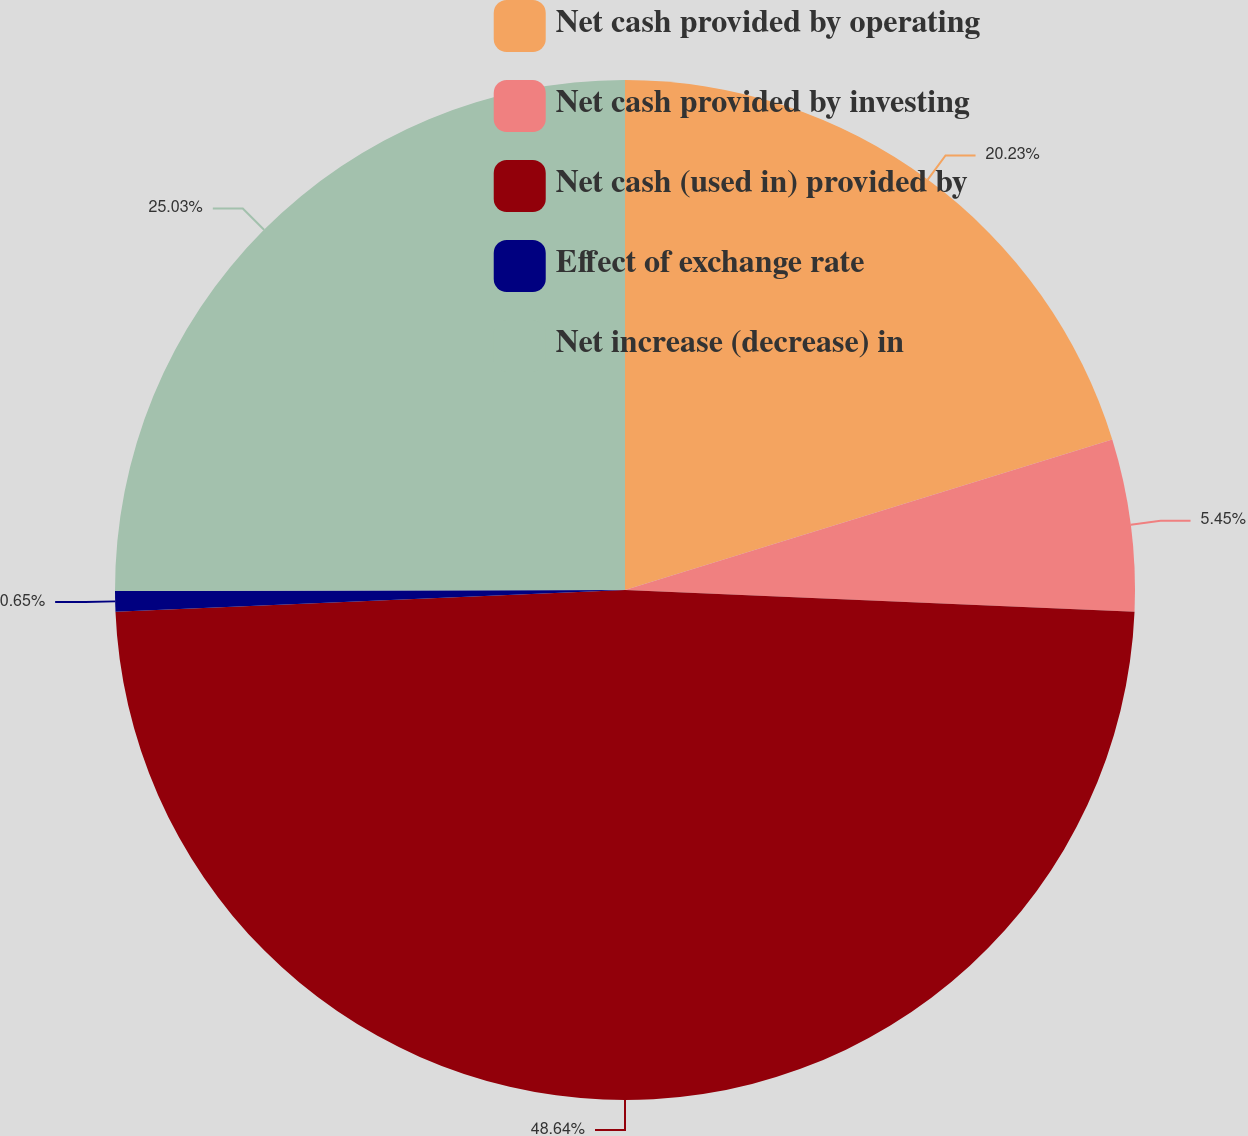<chart> <loc_0><loc_0><loc_500><loc_500><pie_chart><fcel>Net cash provided by operating<fcel>Net cash provided by investing<fcel>Net cash (used in) provided by<fcel>Effect of exchange rate<fcel>Net increase (decrease) in<nl><fcel>20.23%<fcel>5.45%<fcel>48.64%<fcel>0.65%<fcel>25.03%<nl></chart> 